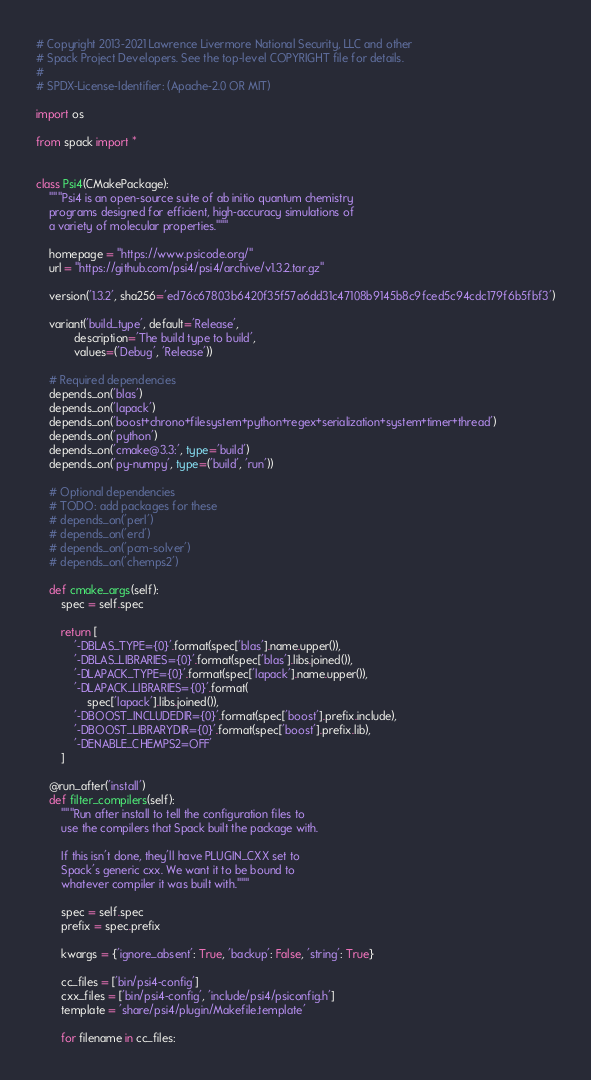<code> <loc_0><loc_0><loc_500><loc_500><_Python_># Copyright 2013-2021 Lawrence Livermore National Security, LLC and other
# Spack Project Developers. See the top-level COPYRIGHT file for details.
#
# SPDX-License-Identifier: (Apache-2.0 OR MIT)

import os

from spack import *


class Psi4(CMakePackage):
    """Psi4 is an open-source suite of ab initio quantum chemistry
    programs designed for efficient, high-accuracy simulations of
    a variety of molecular properties."""

    homepage = "https://www.psicode.org/"
    url = "https://github.com/psi4/psi4/archive/v1.3.2.tar.gz"

    version('1.3.2', sha256='ed76c67803b6420f35f57a6dd31c47108b9145b8c9fced5c94cdc179f6b5fbf3')

    variant('build_type', default='Release',
            description='The build type to build',
            values=('Debug', 'Release'))

    # Required dependencies
    depends_on('blas')
    depends_on('lapack')
    depends_on('boost+chrono+filesystem+python+regex+serialization+system+timer+thread')
    depends_on('python')
    depends_on('cmake@3.3:', type='build')
    depends_on('py-numpy', type=('build', 'run'))

    # Optional dependencies
    # TODO: add packages for these
    # depends_on('perl')
    # depends_on('erd')
    # depends_on('pcm-solver')
    # depends_on('chemps2')

    def cmake_args(self):
        spec = self.spec

        return [
            '-DBLAS_TYPE={0}'.format(spec['blas'].name.upper()),
            '-DBLAS_LIBRARIES={0}'.format(spec['blas'].libs.joined()),
            '-DLAPACK_TYPE={0}'.format(spec['lapack'].name.upper()),
            '-DLAPACK_LIBRARIES={0}'.format(
                spec['lapack'].libs.joined()),
            '-DBOOST_INCLUDEDIR={0}'.format(spec['boost'].prefix.include),
            '-DBOOST_LIBRARYDIR={0}'.format(spec['boost'].prefix.lib),
            '-DENABLE_CHEMPS2=OFF'
        ]

    @run_after('install')
    def filter_compilers(self):
        """Run after install to tell the configuration files to
        use the compilers that Spack built the package with.

        If this isn't done, they'll have PLUGIN_CXX set to
        Spack's generic cxx. We want it to be bound to
        whatever compiler it was built with."""

        spec = self.spec
        prefix = spec.prefix

        kwargs = {'ignore_absent': True, 'backup': False, 'string': True}

        cc_files = ['bin/psi4-config']
        cxx_files = ['bin/psi4-config', 'include/psi4/psiconfig.h']
        template = 'share/psi4/plugin/Makefile.template'

        for filename in cc_files:</code> 